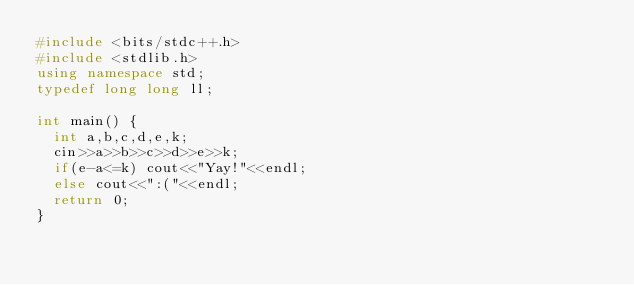<code> <loc_0><loc_0><loc_500><loc_500><_C++_>#include <bits/stdc++.h>
#include <stdlib.h>
using namespace std;
typedef long long ll;

int main() {
  int a,b,c,d,e,k;
  cin>>a>>b>>c>>d>>e>>k;
  if(e-a<=k) cout<<"Yay!"<<endl;
  else cout<<":("<<endl;
  return 0;
}
</code> 